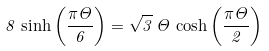<formula> <loc_0><loc_0><loc_500><loc_500>8 \, \sinh \left ( \frac { \pi \Theta } { 6 } \right ) = \sqrt { 3 } \, \Theta \, \cosh \left ( \frac { \pi \Theta } { 2 } \right )</formula> 